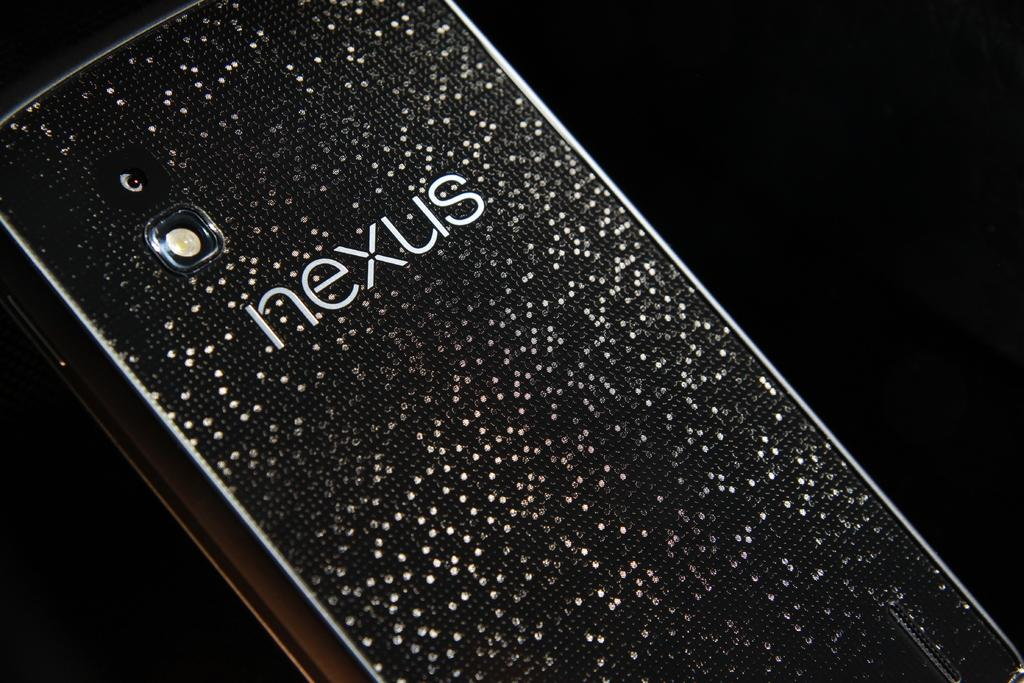<image>
Describe the image concisely. A cell phone made my Nexus with a black and white phone case. 